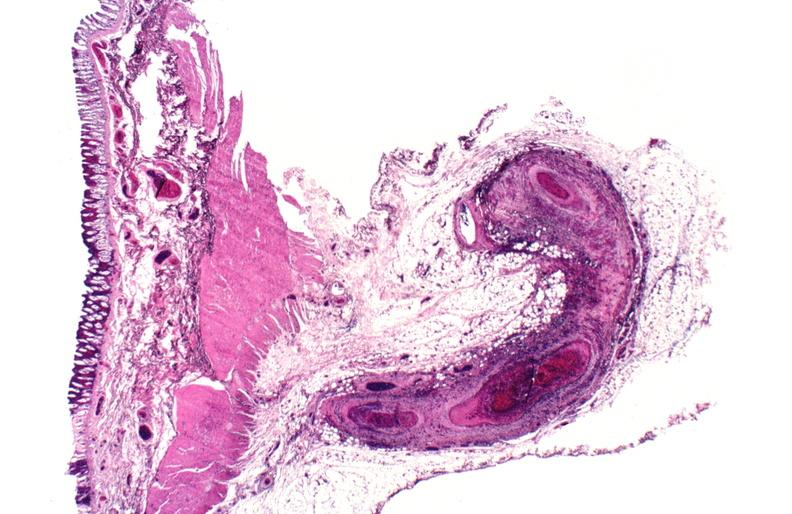does this image show polyarteritis nodosa?
Answer the question using a single word or phrase. Yes 